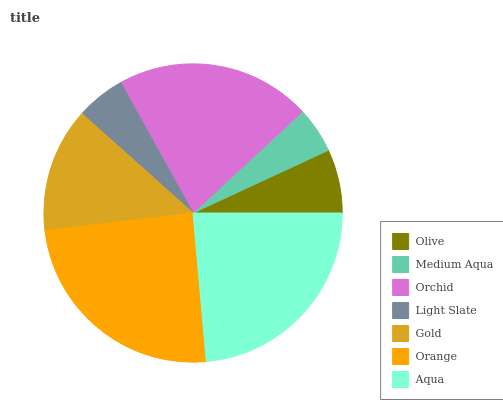Is Medium Aqua the minimum?
Answer yes or no. Yes. Is Orange the maximum?
Answer yes or no. Yes. Is Orchid the minimum?
Answer yes or no. No. Is Orchid the maximum?
Answer yes or no. No. Is Orchid greater than Medium Aqua?
Answer yes or no. Yes. Is Medium Aqua less than Orchid?
Answer yes or no. Yes. Is Medium Aqua greater than Orchid?
Answer yes or no. No. Is Orchid less than Medium Aqua?
Answer yes or no. No. Is Gold the high median?
Answer yes or no. Yes. Is Gold the low median?
Answer yes or no. Yes. Is Olive the high median?
Answer yes or no. No. Is Aqua the low median?
Answer yes or no. No. 